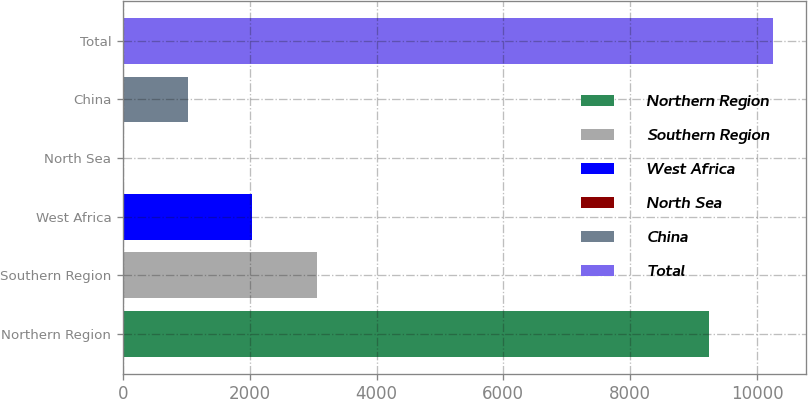<chart> <loc_0><loc_0><loc_500><loc_500><bar_chart><fcel>Northern Region<fcel>Southern Region<fcel>West Africa<fcel>North Sea<fcel>China<fcel>Total<nl><fcel>9238.4<fcel>3054.32<fcel>2037.78<fcel>4.7<fcel>1021.24<fcel>10254.9<nl></chart> 